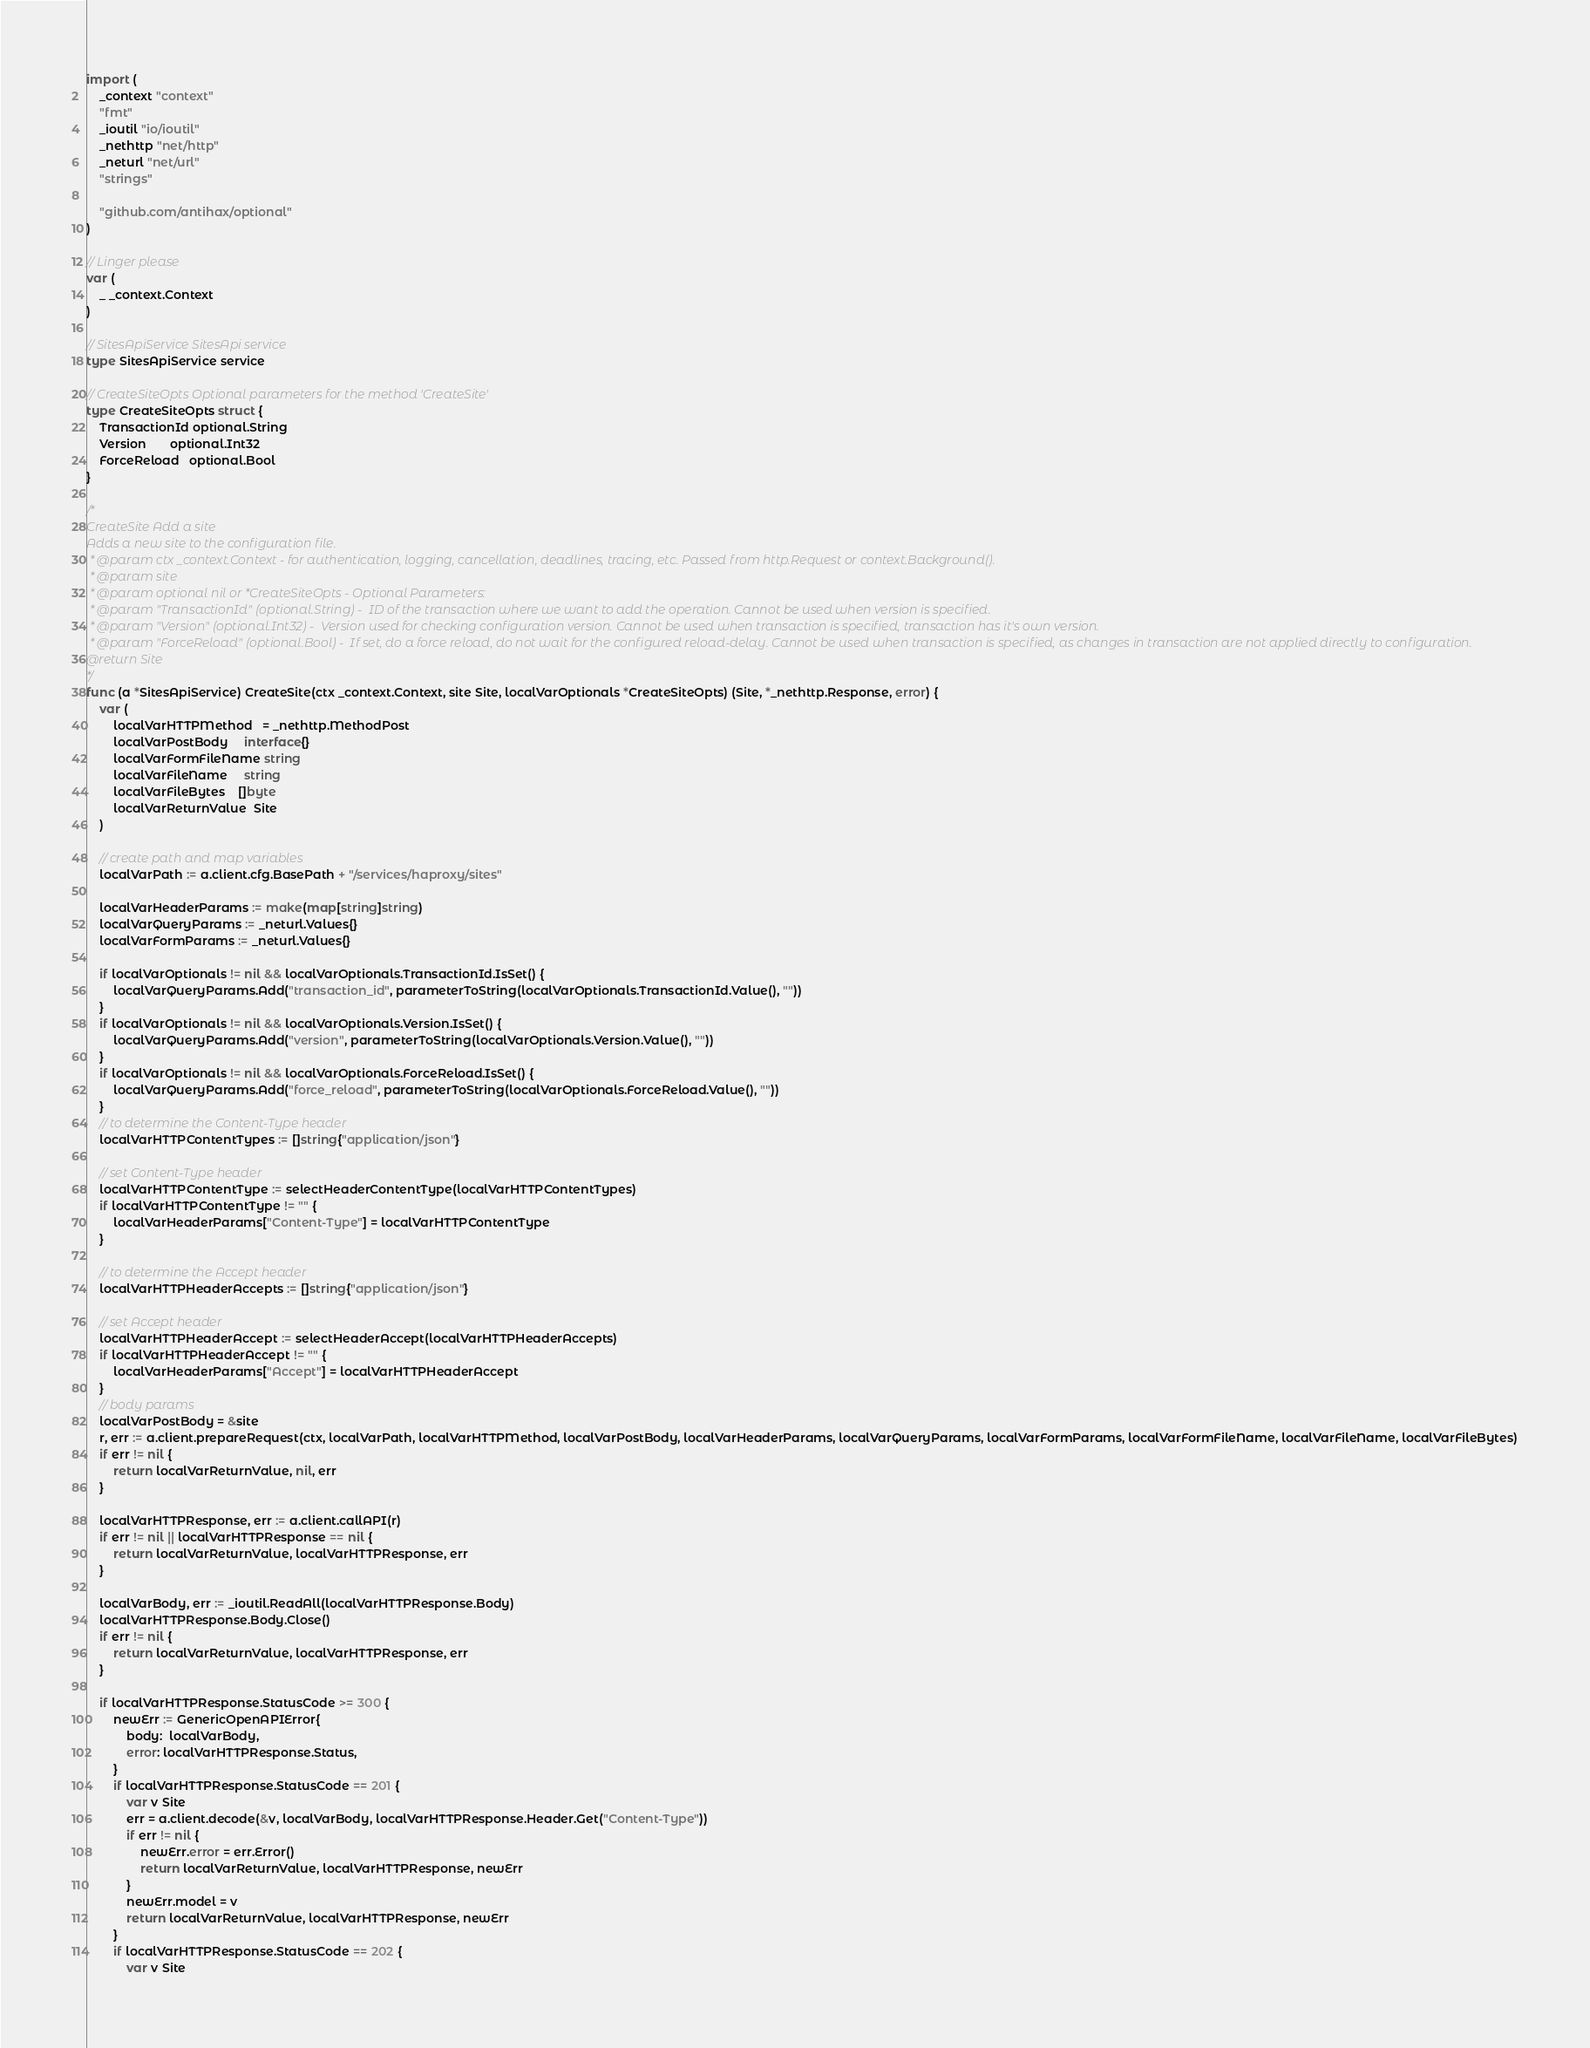Convert code to text. <code><loc_0><loc_0><loc_500><loc_500><_Go_>
import (
	_context "context"
	"fmt"
	_ioutil "io/ioutil"
	_nethttp "net/http"
	_neturl "net/url"
	"strings"

	"github.com/antihax/optional"
)

// Linger please
var (
	_ _context.Context
)

// SitesApiService SitesApi service
type SitesApiService service

// CreateSiteOpts Optional parameters for the method 'CreateSite'
type CreateSiteOpts struct {
	TransactionId optional.String
	Version       optional.Int32
	ForceReload   optional.Bool
}

/*
CreateSite Add a site
Adds a new site to the configuration file.
 * @param ctx _context.Context - for authentication, logging, cancellation, deadlines, tracing, etc. Passed from http.Request or context.Background().
 * @param site
 * @param optional nil or *CreateSiteOpts - Optional Parameters:
 * @param "TransactionId" (optional.String) -  ID of the transaction where we want to add the operation. Cannot be used when version is specified.
 * @param "Version" (optional.Int32) -  Version used for checking configuration version. Cannot be used when transaction is specified, transaction has it's own version.
 * @param "ForceReload" (optional.Bool) -  If set, do a force reload, do not wait for the configured reload-delay. Cannot be used when transaction is specified, as changes in transaction are not applied directly to configuration.
@return Site
*/
func (a *SitesApiService) CreateSite(ctx _context.Context, site Site, localVarOptionals *CreateSiteOpts) (Site, *_nethttp.Response, error) {
	var (
		localVarHTTPMethod   = _nethttp.MethodPost
		localVarPostBody     interface{}
		localVarFormFileName string
		localVarFileName     string
		localVarFileBytes    []byte
		localVarReturnValue  Site
	)

	// create path and map variables
	localVarPath := a.client.cfg.BasePath + "/services/haproxy/sites"

	localVarHeaderParams := make(map[string]string)
	localVarQueryParams := _neturl.Values{}
	localVarFormParams := _neturl.Values{}

	if localVarOptionals != nil && localVarOptionals.TransactionId.IsSet() {
		localVarQueryParams.Add("transaction_id", parameterToString(localVarOptionals.TransactionId.Value(), ""))
	}
	if localVarOptionals != nil && localVarOptionals.Version.IsSet() {
		localVarQueryParams.Add("version", parameterToString(localVarOptionals.Version.Value(), ""))
	}
	if localVarOptionals != nil && localVarOptionals.ForceReload.IsSet() {
		localVarQueryParams.Add("force_reload", parameterToString(localVarOptionals.ForceReload.Value(), ""))
	}
	// to determine the Content-Type header
	localVarHTTPContentTypes := []string{"application/json"}

	// set Content-Type header
	localVarHTTPContentType := selectHeaderContentType(localVarHTTPContentTypes)
	if localVarHTTPContentType != "" {
		localVarHeaderParams["Content-Type"] = localVarHTTPContentType
	}

	// to determine the Accept header
	localVarHTTPHeaderAccepts := []string{"application/json"}

	// set Accept header
	localVarHTTPHeaderAccept := selectHeaderAccept(localVarHTTPHeaderAccepts)
	if localVarHTTPHeaderAccept != "" {
		localVarHeaderParams["Accept"] = localVarHTTPHeaderAccept
	}
	// body params
	localVarPostBody = &site
	r, err := a.client.prepareRequest(ctx, localVarPath, localVarHTTPMethod, localVarPostBody, localVarHeaderParams, localVarQueryParams, localVarFormParams, localVarFormFileName, localVarFileName, localVarFileBytes)
	if err != nil {
		return localVarReturnValue, nil, err
	}

	localVarHTTPResponse, err := a.client.callAPI(r)
	if err != nil || localVarHTTPResponse == nil {
		return localVarReturnValue, localVarHTTPResponse, err
	}

	localVarBody, err := _ioutil.ReadAll(localVarHTTPResponse.Body)
	localVarHTTPResponse.Body.Close()
	if err != nil {
		return localVarReturnValue, localVarHTTPResponse, err
	}

	if localVarHTTPResponse.StatusCode >= 300 {
		newErr := GenericOpenAPIError{
			body:  localVarBody,
			error: localVarHTTPResponse.Status,
		}
		if localVarHTTPResponse.StatusCode == 201 {
			var v Site
			err = a.client.decode(&v, localVarBody, localVarHTTPResponse.Header.Get("Content-Type"))
			if err != nil {
				newErr.error = err.Error()
				return localVarReturnValue, localVarHTTPResponse, newErr
			}
			newErr.model = v
			return localVarReturnValue, localVarHTTPResponse, newErr
		}
		if localVarHTTPResponse.StatusCode == 202 {
			var v Site</code> 